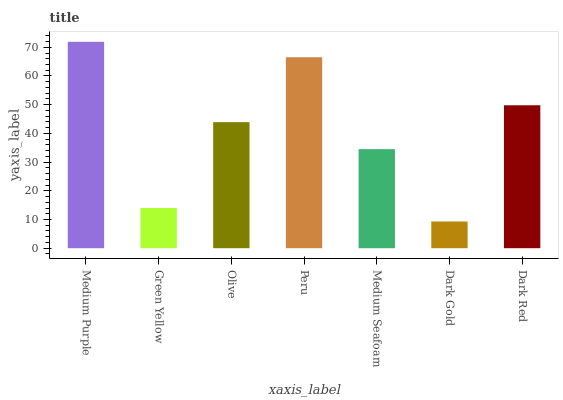Is Dark Gold the minimum?
Answer yes or no. Yes. Is Medium Purple the maximum?
Answer yes or no. Yes. Is Green Yellow the minimum?
Answer yes or no. No. Is Green Yellow the maximum?
Answer yes or no. No. Is Medium Purple greater than Green Yellow?
Answer yes or no. Yes. Is Green Yellow less than Medium Purple?
Answer yes or no. Yes. Is Green Yellow greater than Medium Purple?
Answer yes or no. No. Is Medium Purple less than Green Yellow?
Answer yes or no. No. Is Olive the high median?
Answer yes or no. Yes. Is Olive the low median?
Answer yes or no. Yes. Is Dark Red the high median?
Answer yes or no. No. Is Medium Seafoam the low median?
Answer yes or no. No. 